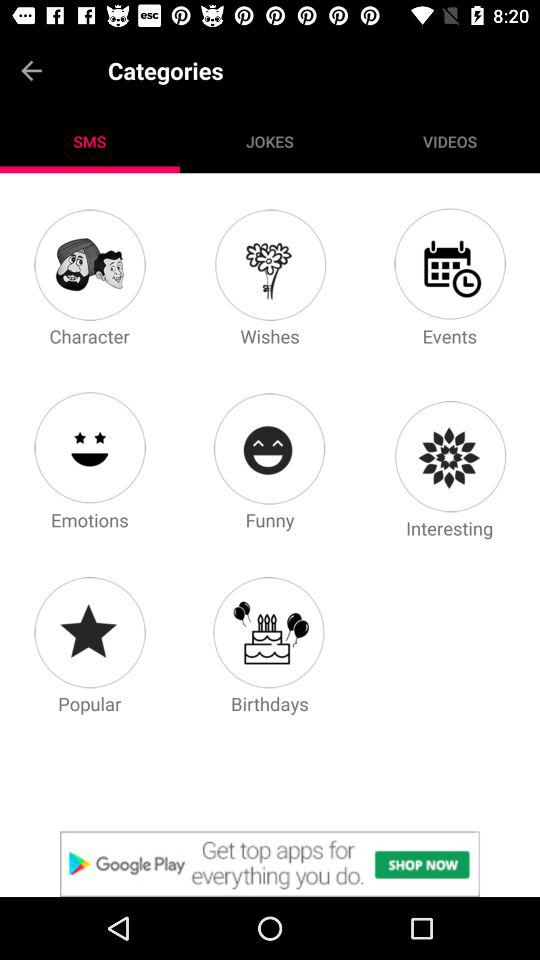Which tab is selected? The selected tab is "SMS". 